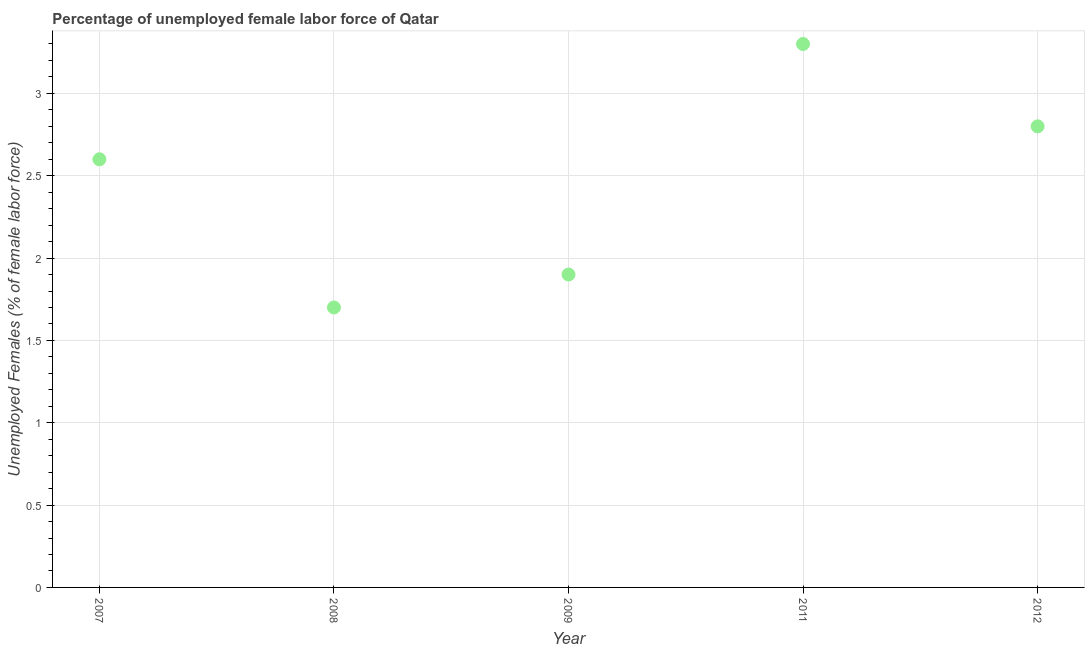What is the total unemployed female labour force in 2007?
Provide a succinct answer. 2.6. Across all years, what is the maximum total unemployed female labour force?
Offer a terse response. 3.3. Across all years, what is the minimum total unemployed female labour force?
Your answer should be compact. 1.7. In which year was the total unemployed female labour force maximum?
Your answer should be very brief. 2011. What is the sum of the total unemployed female labour force?
Provide a succinct answer. 12.3. What is the difference between the total unemployed female labour force in 2008 and 2011?
Offer a terse response. -1.6. What is the average total unemployed female labour force per year?
Your answer should be very brief. 2.46. What is the median total unemployed female labour force?
Make the answer very short. 2.6. What is the ratio of the total unemployed female labour force in 2007 to that in 2009?
Provide a short and direct response. 1.37. Is the total unemployed female labour force in 2007 less than that in 2009?
Give a very brief answer. No. Is the difference between the total unemployed female labour force in 2007 and 2008 greater than the difference between any two years?
Offer a very short reply. No. What is the difference between the highest and the second highest total unemployed female labour force?
Keep it short and to the point. 0.5. Is the sum of the total unemployed female labour force in 2008 and 2011 greater than the maximum total unemployed female labour force across all years?
Provide a short and direct response. Yes. What is the difference between the highest and the lowest total unemployed female labour force?
Your response must be concise. 1.6. How many dotlines are there?
Ensure brevity in your answer.  1. What is the difference between two consecutive major ticks on the Y-axis?
Ensure brevity in your answer.  0.5. Are the values on the major ticks of Y-axis written in scientific E-notation?
Your answer should be compact. No. Does the graph contain grids?
Provide a succinct answer. Yes. What is the title of the graph?
Your answer should be compact. Percentage of unemployed female labor force of Qatar. What is the label or title of the Y-axis?
Give a very brief answer. Unemployed Females (% of female labor force). What is the Unemployed Females (% of female labor force) in 2007?
Make the answer very short. 2.6. What is the Unemployed Females (% of female labor force) in 2008?
Make the answer very short. 1.7. What is the Unemployed Females (% of female labor force) in 2009?
Your response must be concise. 1.9. What is the Unemployed Females (% of female labor force) in 2011?
Offer a very short reply. 3.3. What is the Unemployed Females (% of female labor force) in 2012?
Make the answer very short. 2.8. What is the difference between the Unemployed Females (% of female labor force) in 2007 and 2008?
Keep it short and to the point. 0.9. What is the difference between the Unemployed Females (% of female labor force) in 2007 and 2009?
Keep it short and to the point. 0.7. What is the difference between the Unemployed Females (% of female labor force) in 2008 and 2009?
Your answer should be very brief. -0.2. What is the difference between the Unemployed Females (% of female labor force) in 2008 and 2011?
Ensure brevity in your answer.  -1.6. What is the difference between the Unemployed Females (% of female labor force) in 2008 and 2012?
Your answer should be compact. -1.1. What is the difference between the Unemployed Females (% of female labor force) in 2011 and 2012?
Give a very brief answer. 0.5. What is the ratio of the Unemployed Females (% of female labor force) in 2007 to that in 2008?
Your response must be concise. 1.53. What is the ratio of the Unemployed Females (% of female labor force) in 2007 to that in 2009?
Provide a succinct answer. 1.37. What is the ratio of the Unemployed Females (% of female labor force) in 2007 to that in 2011?
Ensure brevity in your answer.  0.79. What is the ratio of the Unemployed Females (% of female labor force) in 2007 to that in 2012?
Offer a terse response. 0.93. What is the ratio of the Unemployed Females (% of female labor force) in 2008 to that in 2009?
Offer a terse response. 0.9. What is the ratio of the Unemployed Females (% of female labor force) in 2008 to that in 2011?
Provide a short and direct response. 0.52. What is the ratio of the Unemployed Females (% of female labor force) in 2008 to that in 2012?
Your answer should be compact. 0.61. What is the ratio of the Unemployed Females (% of female labor force) in 2009 to that in 2011?
Your response must be concise. 0.58. What is the ratio of the Unemployed Females (% of female labor force) in 2009 to that in 2012?
Offer a terse response. 0.68. What is the ratio of the Unemployed Females (% of female labor force) in 2011 to that in 2012?
Make the answer very short. 1.18. 